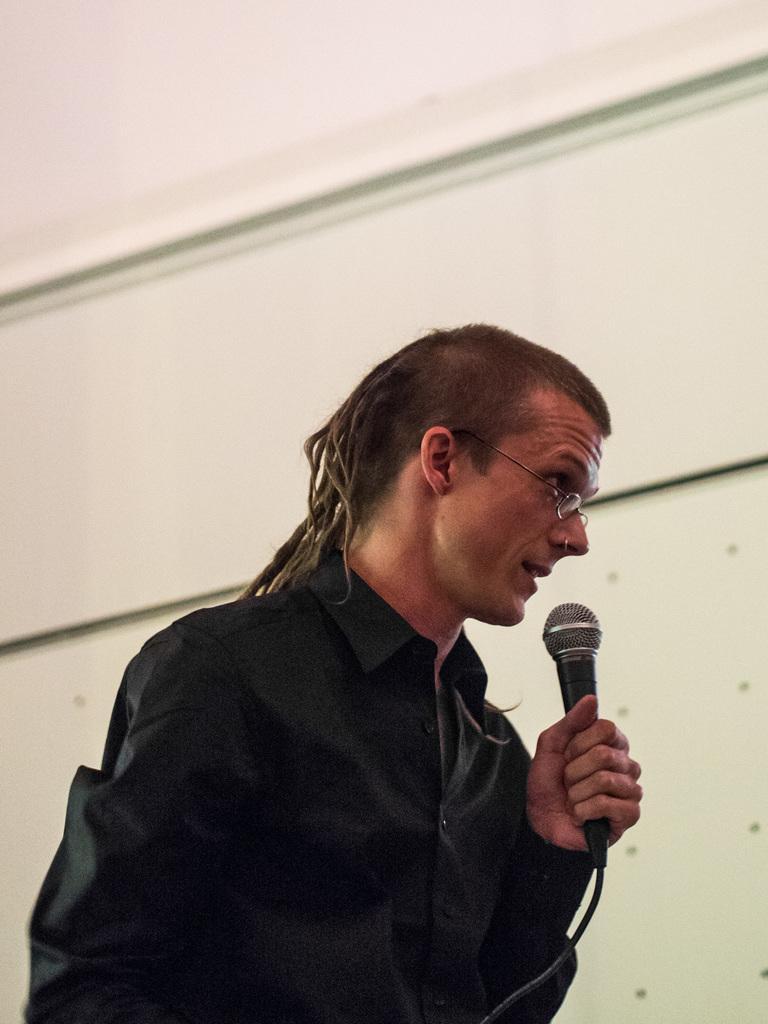How would you summarize this image in a sentence or two? The man in the middle of the picture wearing black shirt and spectacles is holding a microphone in his hand. He is talking on the microphone. Behind him, we see a wall which is white in color. 